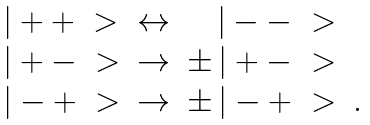<formula> <loc_0><loc_0><loc_500><loc_500>\begin{array} { l r r l } | + + \ > & \leftrightarrow & | - - \ > \\ | + - \ > & \to & \pm \, | + - \ > \\ | - + \ > & \to & \pm \, | - + \ > & . \end{array}</formula> 